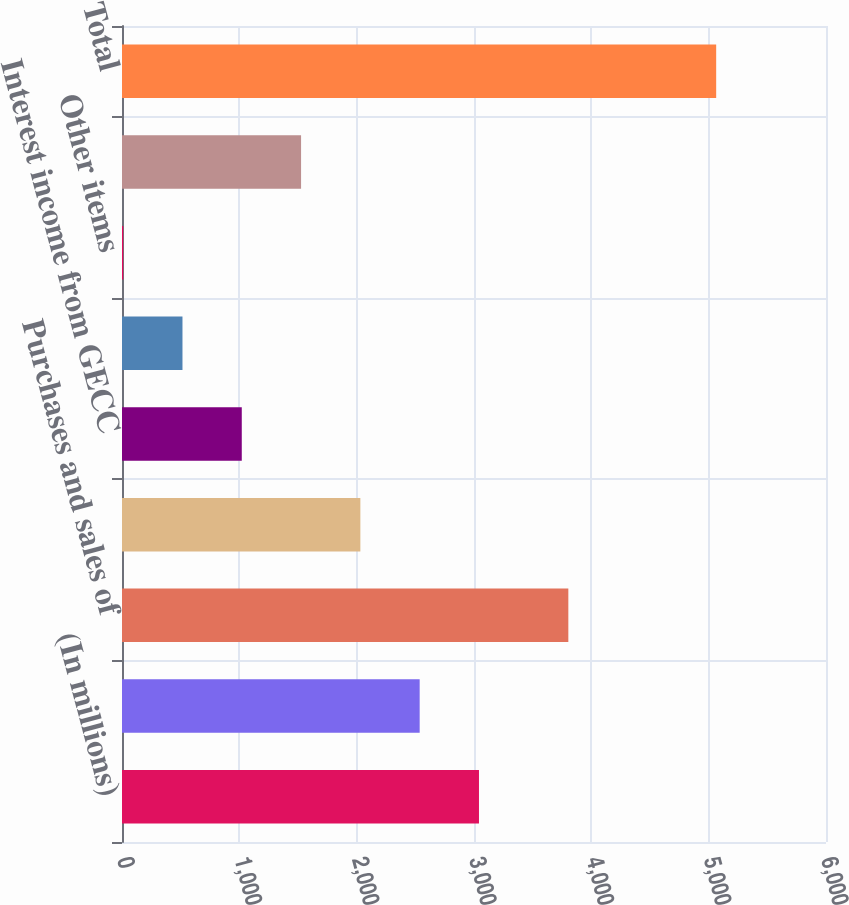Convert chart. <chart><loc_0><loc_0><loc_500><loc_500><bar_chart><fcel>(In millions)<fcel>Associated companies (a)<fcel>Purchases and sales of<fcel>Licensing and royalty income<fcel>Interest income from GECC<fcel>Marketable securities and bank<fcel>Other items<fcel>ELIMINATIONS<fcel>Total<nl><fcel>3042.4<fcel>2537<fcel>3804<fcel>2031.6<fcel>1020.8<fcel>515.4<fcel>10<fcel>1526.2<fcel>5064<nl></chart> 